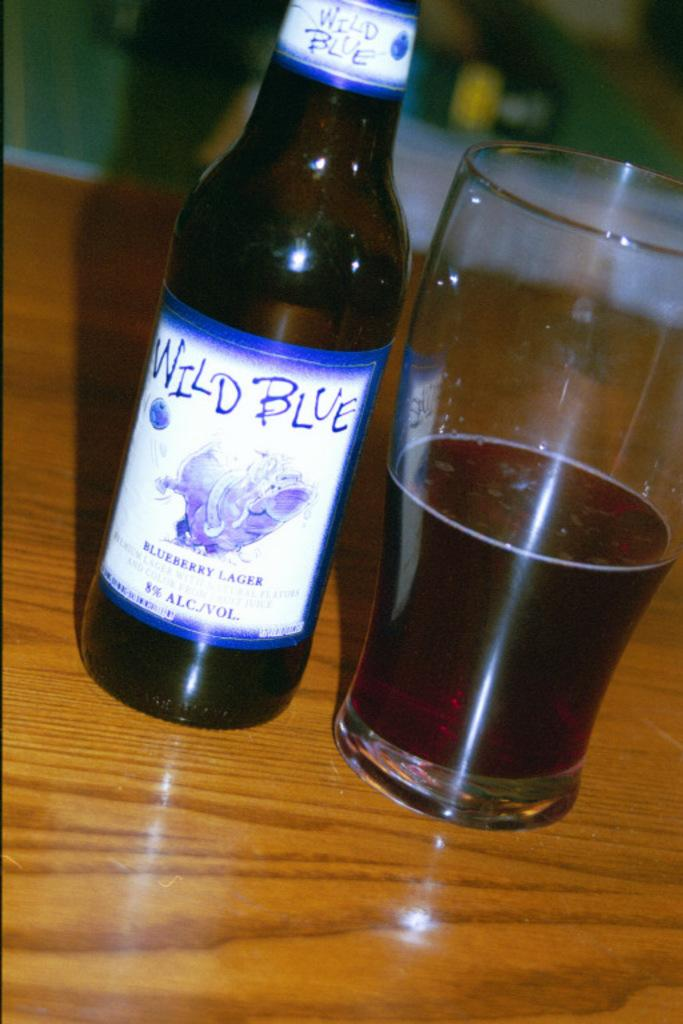<image>
Write a terse but informative summary of the picture. A bottle of Wild Blue Lager next to a half full drinking glass. 